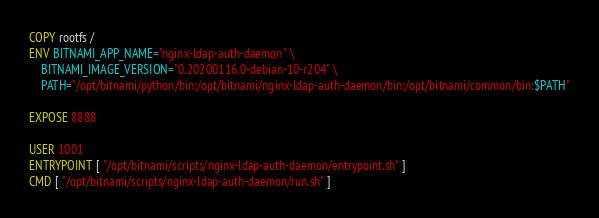Convert code to text. <code><loc_0><loc_0><loc_500><loc_500><_Dockerfile_>COPY rootfs /
ENV BITNAMI_APP_NAME="nginx-ldap-auth-daemon" \
    BITNAMI_IMAGE_VERSION="0.20200116.0-debian-10-r204" \
    PATH="/opt/bitnami/python/bin:/opt/bitnami/nginx-ldap-auth-daemon/bin:/opt/bitnami/common/bin:$PATH"

EXPOSE 8888

USER 1001
ENTRYPOINT [ "/opt/bitnami/scripts/nginx-ldap-auth-daemon/entrypoint.sh" ]
CMD [ "/opt/bitnami/scripts/nginx-ldap-auth-daemon/run.sh" ]
</code> 